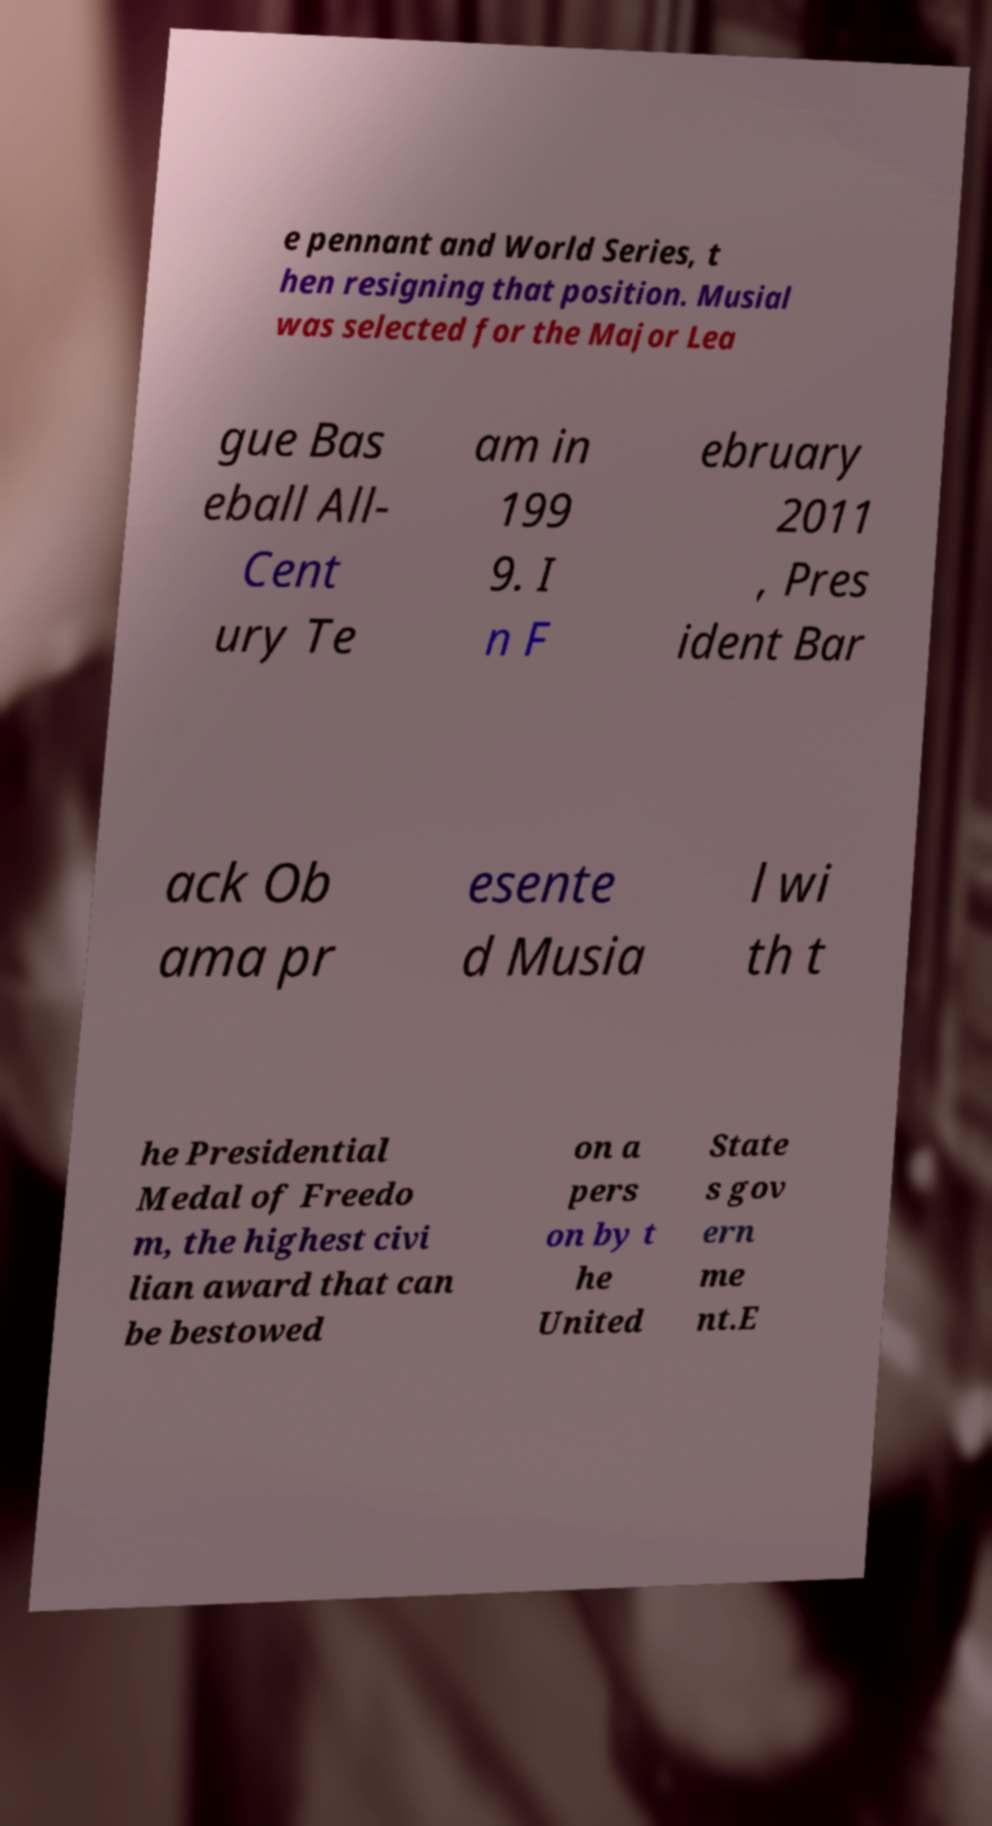Can you read and provide the text displayed in the image?This photo seems to have some interesting text. Can you extract and type it out for me? e pennant and World Series, t hen resigning that position. Musial was selected for the Major Lea gue Bas eball All- Cent ury Te am in 199 9. I n F ebruary 2011 , Pres ident Bar ack Ob ama pr esente d Musia l wi th t he Presidential Medal of Freedo m, the highest civi lian award that can be bestowed on a pers on by t he United State s gov ern me nt.E 